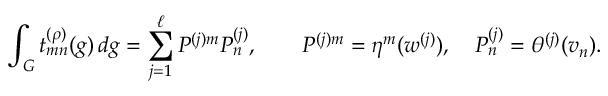Convert formula to latex. <formula><loc_0><loc_0><loc_500><loc_500>\int _ { G } t _ { m n } ^ { ( \rho ) } ( g ) \, d g = \sum _ { j = 1 } ^ { \ell } P ^ { ( j ) m } P _ { n } ^ { ( j ) } , \quad P ^ { ( j ) m } = \eta ^ { m } ( w ^ { ( j ) } ) , \quad P _ { n } ^ { ( j ) } = \theta ^ { ( j ) } ( v _ { n } ) .</formula> 